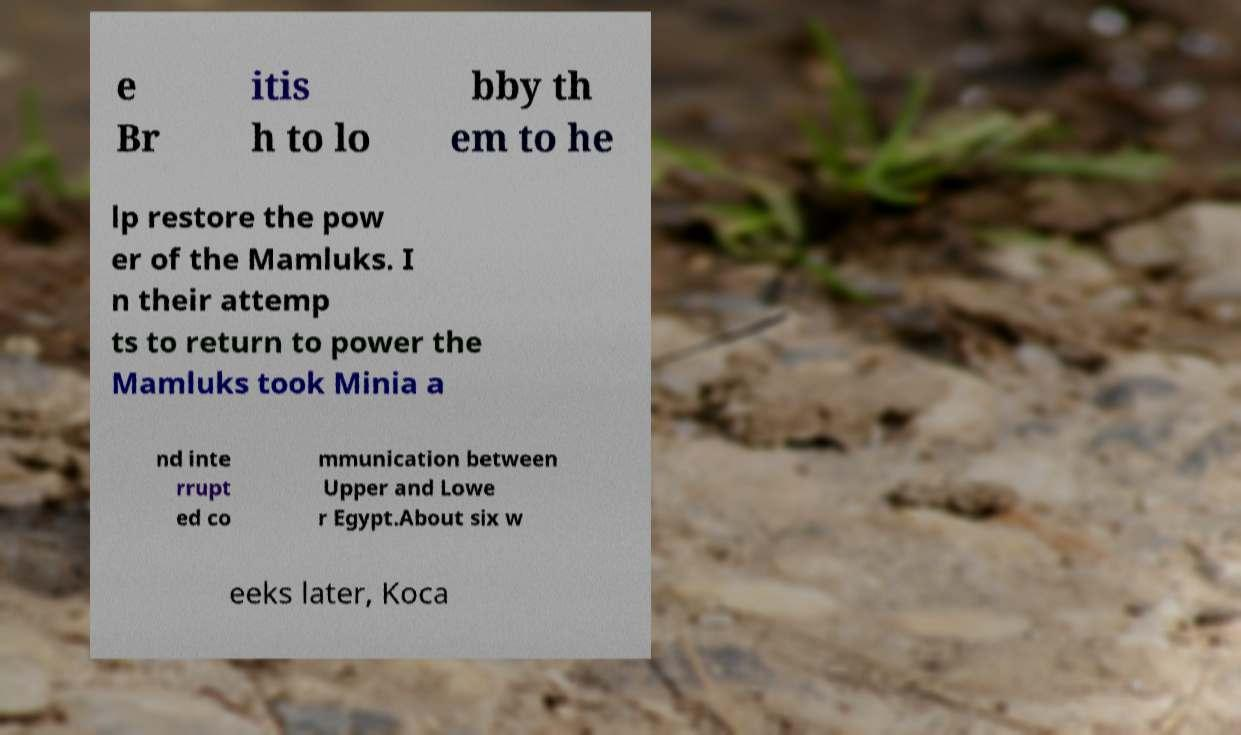I need the written content from this picture converted into text. Can you do that? e Br itis h to lo bby th em to he lp restore the pow er of the Mamluks. I n their attemp ts to return to power the Mamluks took Minia a nd inte rrupt ed co mmunication between Upper and Lowe r Egypt.About six w eeks later, Koca 